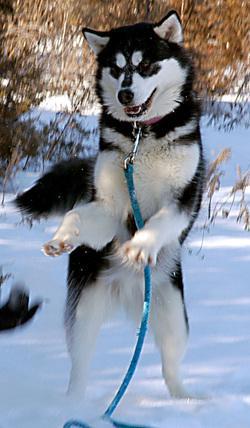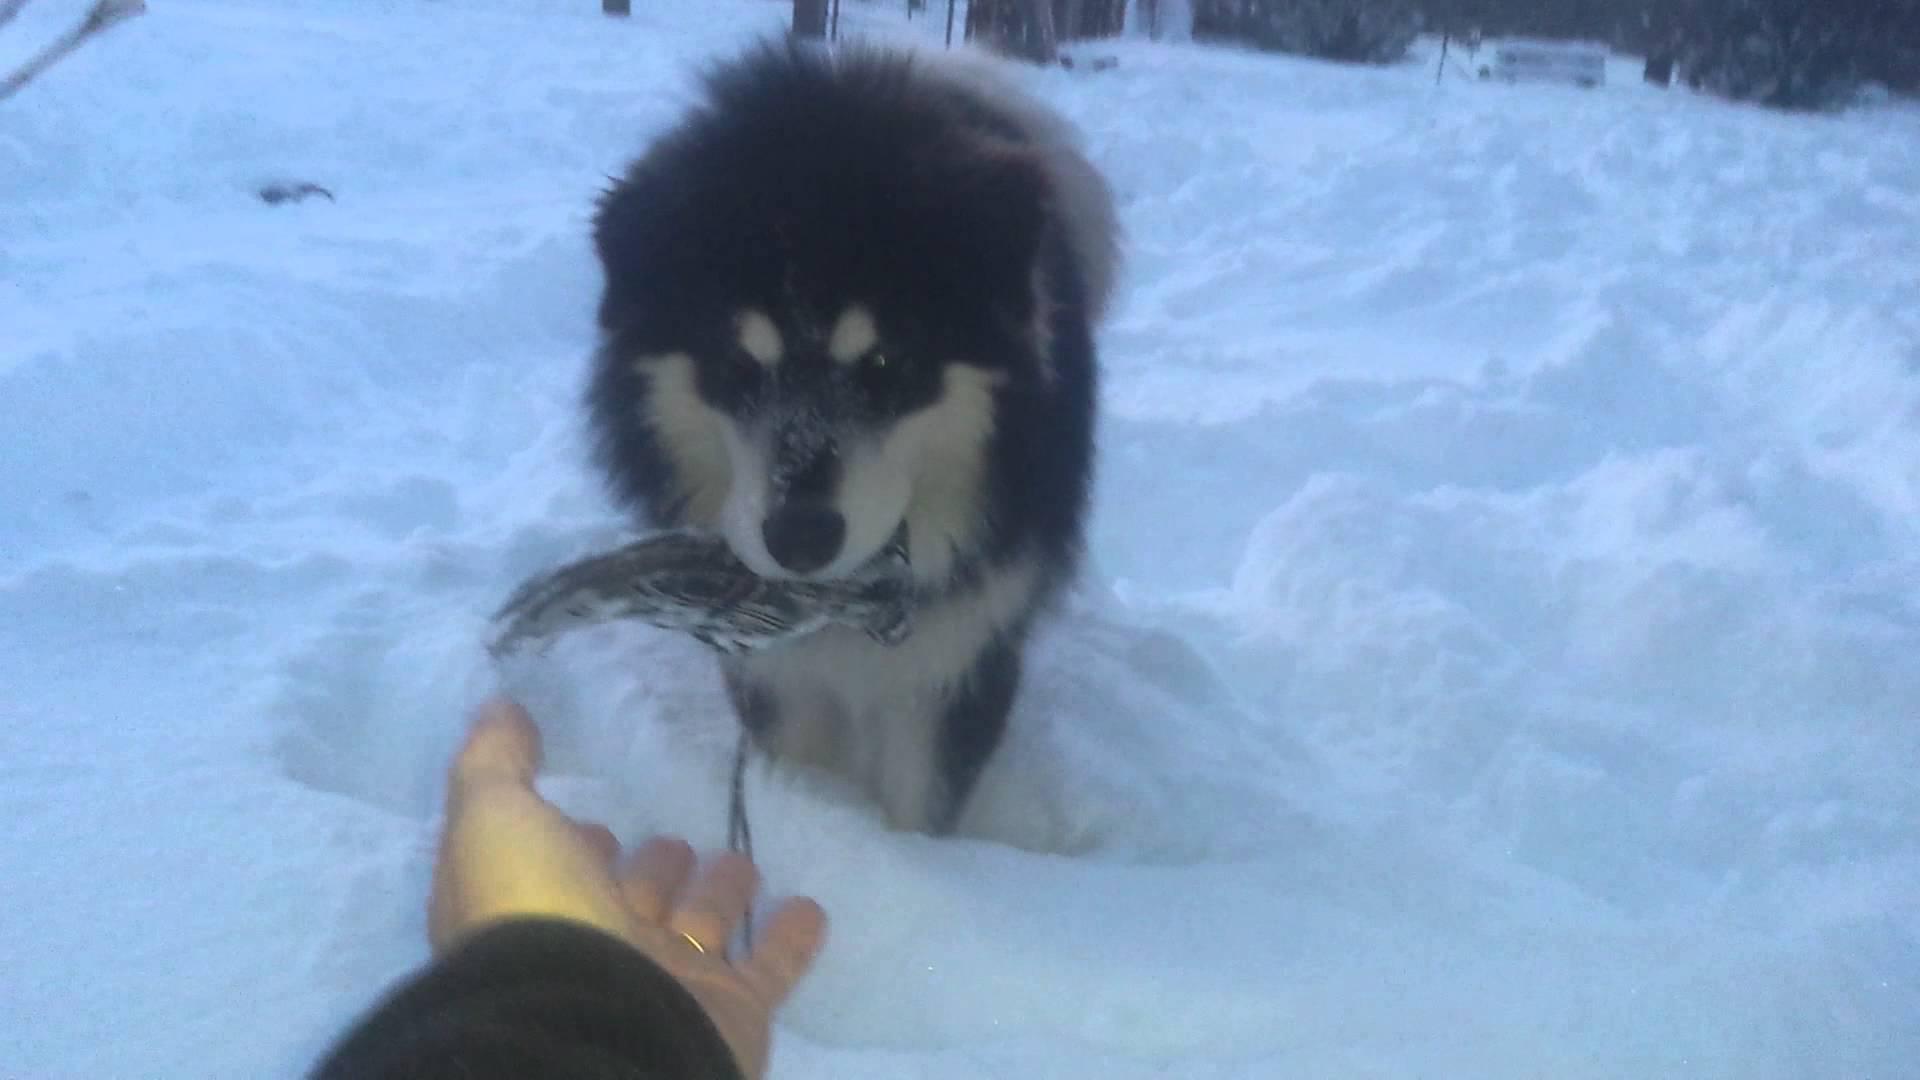The first image is the image on the left, the second image is the image on the right. Assess this claim about the two images: "There are four animals.". Correct or not? Answer yes or no. No. The first image is the image on the left, the second image is the image on the right. Assess this claim about the two images: "At least one of the images shows a dog interacting with a mammal that is not a dog.". Correct or not? Answer yes or no. Yes. 